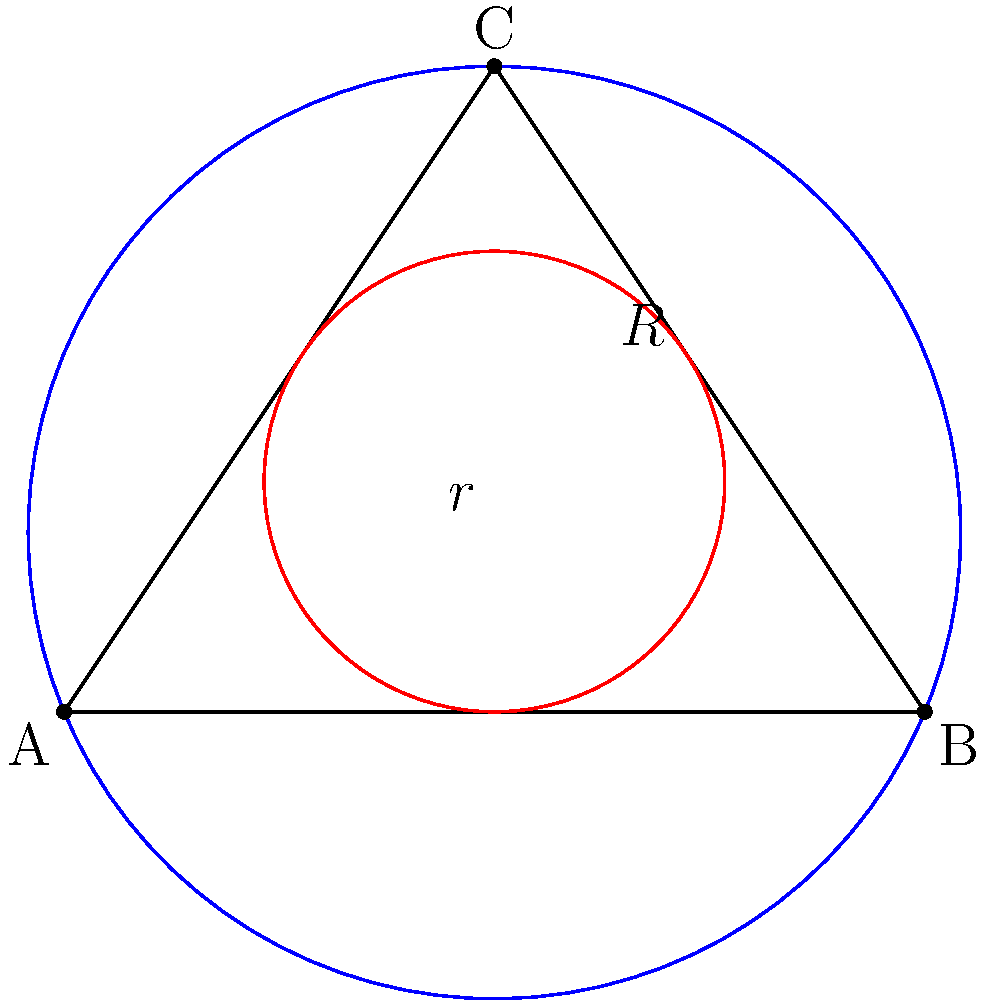In the diagram above, a triangle ABC is shown with its inscribed circle (red) and circumscribed circle (blue). If the radius of the circumscribed circle is $R$ and the radius of the inscribed circle is $r$, what is the relationship between $R$, $r$, and the semi-perimeter $s$ of the triangle? This relationship is crucial for understanding the harmonic balance in geometric compositions, much like the interplay between different musical elements in a well-crafted album. Let's approach this step-by-step, like analyzing the layers of a complex musical piece:

1) First, recall that the area of a triangle can be expressed in two ways:
   a) Using the semi-perimeter formula: $A = \sqrt{s(s-a)(s-b)(s-c)}$
   b) Using the inradius: $A = rs$, where $s$ is the semi-perimeter

2) We also know that the area of a triangle can be expressed using the circumradius:
   $A = \frac{abc}{4R}$, where $a$, $b$, and $c$ are the side lengths

3) Equating these expressions:
   $rs = \frac{abc}{4R}$

4) Now, let's consider the formula for the semi-perimeter:
   $s = \frac{a+b+c}{2}$

5) There's a well-known relationship between the sides of a triangle and its circumradius:
   $\frac{a}{2R} = \sin A$, $\frac{b}{2R} = \sin B$, $\frac{c}{2R} = \sin C$

6) Adding these equations:
   $\frac{a+b+c}{2R} = \sin A + \sin B + \sin C = 4 \sin \frac{A}{2} \sin \frac{B}{2} \sin \frac{C}{2}$

7) Substituting $s$ for $\frac{a+b+c}{2}$:
   $\frac{s}{R} = 4 \sin \frac{A}{2} \sin \frac{B}{2} \sin \frac{C}{2}$

8) Now, there's another important relationship:
   $\sin \frac{A}{2} \sin \frac{B}{2} \sin \frac{C}{2} = \frac{r}{4R}$

9) Substituting this into our equation from step 7:
   $\frac{s}{R} = \frac{r}{R}$

10) Therefore, we arrive at the elegant relationship:
    $R = s = \frac{abc}{4rs}$

This relationship, much like a perfectly balanced chorus in a song, shows the harmonic connection between the circumradius, inradius, and semi-perimeter of a triangle.
Answer: $R = s = \frac{abc}{4rs}$ 